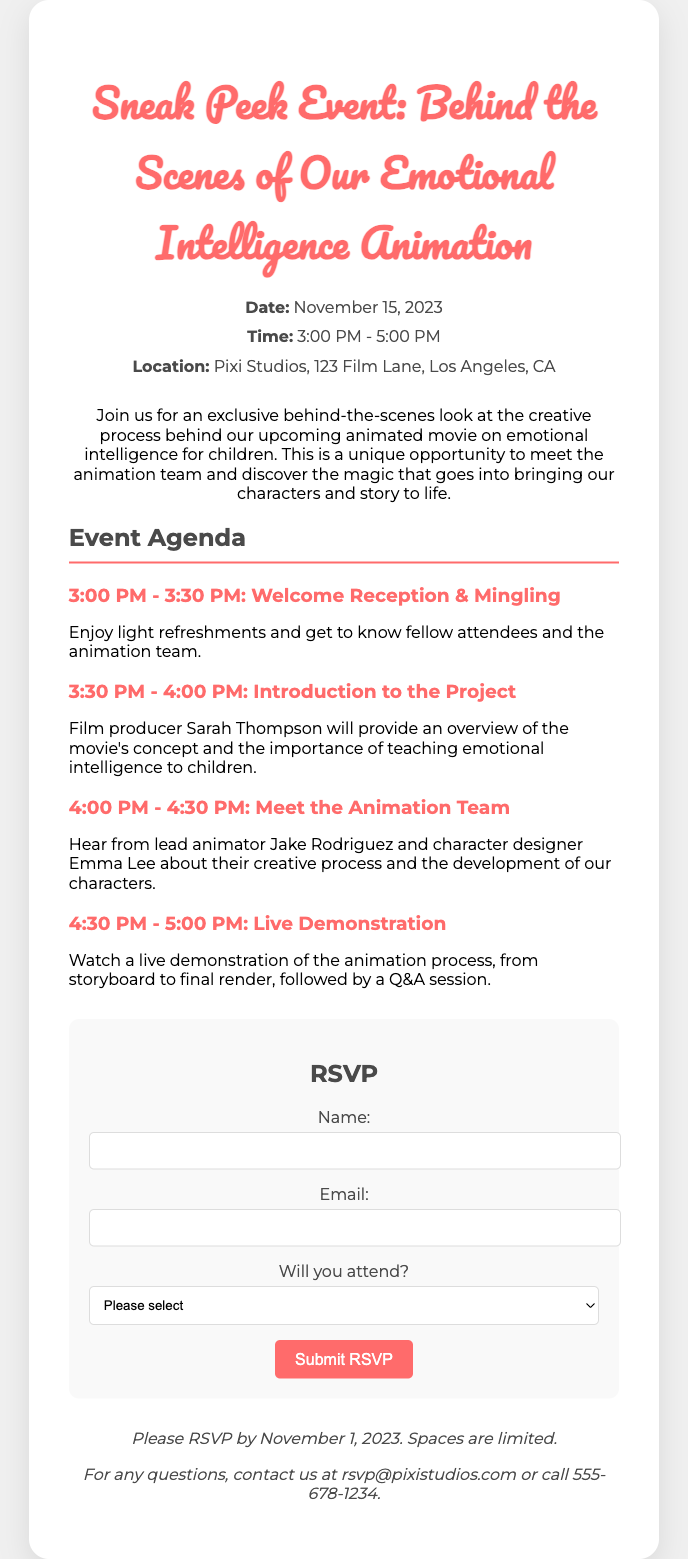what is the date of the event? The date of the event is mentioned in the event details section of the document.
Answer: November 15, 2023 what time does the event start? This information can be found in the event details section, specifying the start time.
Answer: 3:00 PM where is the event located? The location is provided in the event details part of the document.
Answer: Pixi Studios, 123 Film Lane, Los Angeles, CA who is the film producer presenting at the event? The document lists the name of the film producer who will provide an overview.
Answer: Sarah Thompson what is the main focus of the movie? The overview talks about the theme of the movie in relation to children's education.
Answer: Emotional intelligence how long is the welcome reception? The agenda outlines the duration of the welcome reception segment.
Answer: 30 minutes what is the deadline for RSVPs? The additional info section indicates the last date to send an RSVP.
Answer: November 1, 2023 what type of session follows the introduction to the project? This information is listed in the agenda following the introduction segment.
Answer: Meet the Animation Team how can attendees contact for questions? The document provides a contact email for inquiries mentioned in the additional info section.
Answer: rsvp@pixistudios.com 